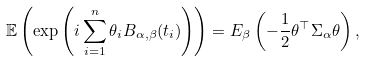<formula> <loc_0><loc_0><loc_500><loc_500>\mathbb { E } \left ( \exp \left ( i \sum _ { i = 1 } ^ { n } \theta _ { i } B _ { \alpha , \beta } ( t _ { i } ) \right ) \right ) = E _ { \beta } \left ( - \frac { 1 } { 2 } \theta ^ { \top } \Sigma _ { \alpha } \theta \right ) , \quad</formula> 